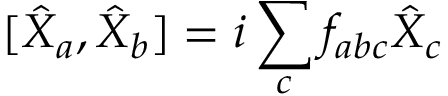Convert formula to latex. <formula><loc_0><loc_0><loc_500><loc_500>[ \hat { X } _ { a } , \hat { X } _ { b } ] = i \sum _ { c } f _ { a b c } \hat { X } _ { c }</formula> 